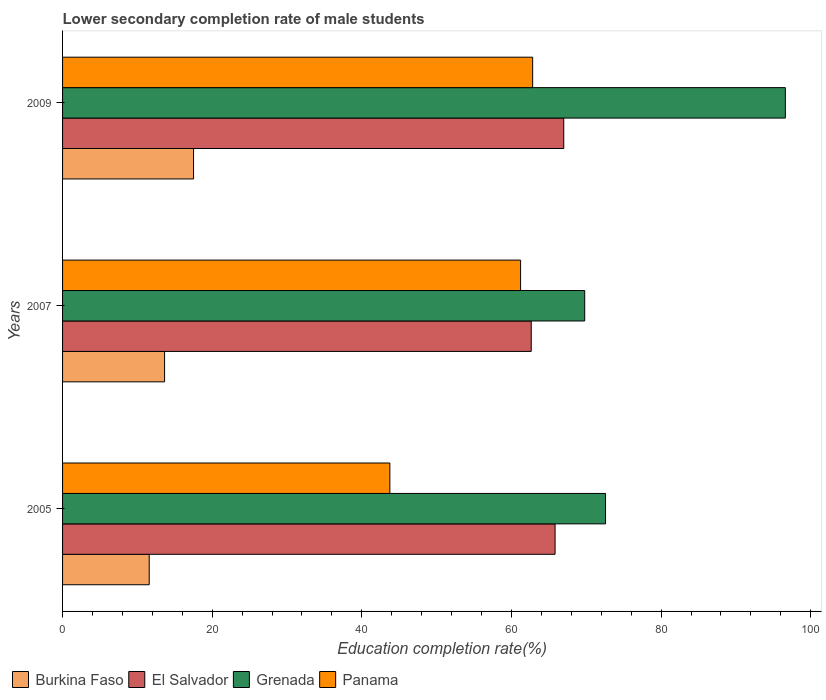How many different coloured bars are there?
Your answer should be very brief. 4. How many groups of bars are there?
Your response must be concise. 3. Are the number of bars on each tick of the Y-axis equal?
Offer a very short reply. Yes. How many bars are there on the 1st tick from the top?
Offer a terse response. 4. In how many cases, is the number of bars for a given year not equal to the number of legend labels?
Offer a very short reply. 0. What is the lower secondary completion rate of male students in Burkina Faso in 2005?
Keep it short and to the point. 11.58. Across all years, what is the maximum lower secondary completion rate of male students in El Salvador?
Make the answer very short. 66.99. Across all years, what is the minimum lower secondary completion rate of male students in Panama?
Keep it short and to the point. 43.74. In which year was the lower secondary completion rate of male students in El Salvador maximum?
Offer a very short reply. 2009. In which year was the lower secondary completion rate of male students in El Salvador minimum?
Provide a short and direct response. 2007. What is the total lower secondary completion rate of male students in Burkina Faso in the graph?
Provide a succinct answer. 42.73. What is the difference between the lower secondary completion rate of male students in Panama in 2005 and that in 2009?
Provide a succinct answer. -19.09. What is the difference between the lower secondary completion rate of male students in Panama in 2005 and the lower secondary completion rate of male students in Burkina Faso in 2007?
Keep it short and to the point. 30.11. What is the average lower secondary completion rate of male students in Burkina Faso per year?
Offer a very short reply. 14.24. In the year 2007, what is the difference between the lower secondary completion rate of male students in Panama and lower secondary completion rate of male students in El Salvador?
Keep it short and to the point. -1.42. In how many years, is the lower secondary completion rate of male students in Panama greater than 40 %?
Your answer should be compact. 3. What is the ratio of the lower secondary completion rate of male students in Panama in 2005 to that in 2007?
Offer a very short reply. 0.71. What is the difference between the highest and the second highest lower secondary completion rate of male students in Panama?
Offer a terse response. 1.61. What is the difference between the highest and the lowest lower secondary completion rate of male students in Grenada?
Provide a succinct answer. 26.82. In how many years, is the lower secondary completion rate of male students in El Salvador greater than the average lower secondary completion rate of male students in El Salvador taken over all years?
Your response must be concise. 2. What does the 4th bar from the top in 2005 represents?
Your response must be concise. Burkina Faso. What does the 3rd bar from the bottom in 2007 represents?
Offer a terse response. Grenada. Is it the case that in every year, the sum of the lower secondary completion rate of male students in El Salvador and lower secondary completion rate of male students in Panama is greater than the lower secondary completion rate of male students in Grenada?
Ensure brevity in your answer.  Yes. How many years are there in the graph?
Give a very brief answer. 3. What is the difference between two consecutive major ticks on the X-axis?
Offer a very short reply. 20. Where does the legend appear in the graph?
Your answer should be compact. Bottom left. How many legend labels are there?
Provide a succinct answer. 4. What is the title of the graph?
Your answer should be compact. Lower secondary completion rate of male students. Does "Morocco" appear as one of the legend labels in the graph?
Keep it short and to the point. No. What is the label or title of the X-axis?
Give a very brief answer. Education completion rate(%). What is the label or title of the Y-axis?
Ensure brevity in your answer.  Years. What is the Education completion rate(%) of Burkina Faso in 2005?
Your answer should be compact. 11.58. What is the Education completion rate(%) in El Salvador in 2005?
Your answer should be compact. 65.83. What is the Education completion rate(%) of Grenada in 2005?
Your response must be concise. 72.57. What is the Education completion rate(%) of Panama in 2005?
Give a very brief answer. 43.74. What is the Education completion rate(%) of Burkina Faso in 2007?
Your answer should be compact. 13.64. What is the Education completion rate(%) of El Salvador in 2007?
Ensure brevity in your answer.  62.64. What is the Education completion rate(%) in Grenada in 2007?
Keep it short and to the point. 69.79. What is the Education completion rate(%) of Panama in 2007?
Your answer should be compact. 61.22. What is the Education completion rate(%) of Burkina Faso in 2009?
Make the answer very short. 17.51. What is the Education completion rate(%) of El Salvador in 2009?
Your answer should be compact. 66.99. What is the Education completion rate(%) in Grenada in 2009?
Provide a short and direct response. 96.61. What is the Education completion rate(%) of Panama in 2009?
Make the answer very short. 62.83. Across all years, what is the maximum Education completion rate(%) in Burkina Faso?
Your answer should be compact. 17.51. Across all years, what is the maximum Education completion rate(%) of El Salvador?
Your answer should be very brief. 66.99. Across all years, what is the maximum Education completion rate(%) of Grenada?
Ensure brevity in your answer.  96.61. Across all years, what is the maximum Education completion rate(%) of Panama?
Offer a very short reply. 62.83. Across all years, what is the minimum Education completion rate(%) of Burkina Faso?
Provide a succinct answer. 11.58. Across all years, what is the minimum Education completion rate(%) of El Salvador?
Give a very brief answer. 62.64. Across all years, what is the minimum Education completion rate(%) in Grenada?
Offer a very short reply. 69.79. Across all years, what is the minimum Education completion rate(%) of Panama?
Offer a very short reply. 43.74. What is the total Education completion rate(%) of Burkina Faso in the graph?
Provide a short and direct response. 42.73. What is the total Education completion rate(%) of El Salvador in the graph?
Your answer should be very brief. 195.46. What is the total Education completion rate(%) in Grenada in the graph?
Your answer should be compact. 238.97. What is the total Education completion rate(%) in Panama in the graph?
Offer a very short reply. 167.79. What is the difference between the Education completion rate(%) of Burkina Faso in 2005 and that in 2007?
Make the answer very short. -2.06. What is the difference between the Education completion rate(%) of El Salvador in 2005 and that in 2007?
Give a very brief answer. 3.19. What is the difference between the Education completion rate(%) in Grenada in 2005 and that in 2007?
Give a very brief answer. 2.79. What is the difference between the Education completion rate(%) of Panama in 2005 and that in 2007?
Offer a terse response. -17.47. What is the difference between the Education completion rate(%) of Burkina Faso in 2005 and that in 2009?
Offer a very short reply. -5.93. What is the difference between the Education completion rate(%) in El Salvador in 2005 and that in 2009?
Keep it short and to the point. -1.16. What is the difference between the Education completion rate(%) in Grenada in 2005 and that in 2009?
Your answer should be very brief. -24.03. What is the difference between the Education completion rate(%) of Panama in 2005 and that in 2009?
Your answer should be very brief. -19.09. What is the difference between the Education completion rate(%) of Burkina Faso in 2007 and that in 2009?
Keep it short and to the point. -3.87. What is the difference between the Education completion rate(%) in El Salvador in 2007 and that in 2009?
Provide a succinct answer. -4.35. What is the difference between the Education completion rate(%) in Grenada in 2007 and that in 2009?
Offer a very short reply. -26.82. What is the difference between the Education completion rate(%) in Panama in 2007 and that in 2009?
Your answer should be very brief. -1.61. What is the difference between the Education completion rate(%) of Burkina Faso in 2005 and the Education completion rate(%) of El Salvador in 2007?
Your answer should be very brief. -51.06. What is the difference between the Education completion rate(%) in Burkina Faso in 2005 and the Education completion rate(%) in Grenada in 2007?
Give a very brief answer. -58.21. What is the difference between the Education completion rate(%) of Burkina Faso in 2005 and the Education completion rate(%) of Panama in 2007?
Your answer should be very brief. -49.64. What is the difference between the Education completion rate(%) in El Salvador in 2005 and the Education completion rate(%) in Grenada in 2007?
Your answer should be compact. -3.96. What is the difference between the Education completion rate(%) in El Salvador in 2005 and the Education completion rate(%) in Panama in 2007?
Offer a terse response. 4.61. What is the difference between the Education completion rate(%) in Grenada in 2005 and the Education completion rate(%) in Panama in 2007?
Keep it short and to the point. 11.35. What is the difference between the Education completion rate(%) of Burkina Faso in 2005 and the Education completion rate(%) of El Salvador in 2009?
Ensure brevity in your answer.  -55.41. What is the difference between the Education completion rate(%) in Burkina Faso in 2005 and the Education completion rate(%) in Grenada in 2009?
Offer a very short reply. -85.02. What is the difference between the Education completion rate(%) of Burkina Faso in 2005 and the Education completion rate(%) of Panama in 2009?
Provide a succinct answer. -51.25. What is the difference between the Education completion rate(%) in El Salvador in 2005 and the Education completion rate(%) in Grenada in 2009?
Provide a succinct answer. -30.78. What is the difference between the Education completion rate(%) of El Salvador in 2005 and the Education completion rate(%) of Panama in 2009?
Ensure brevity in your answer.  3. What is the difference between the Education completion rate(%) in Grenada in 2005 and the Education completion rate(%) in Panama in 2009?
Your answer should be compact. 9.74. What is the difference between the Education completion rate(%) of Burkina Faso in 2007 and the Education completion rate(%) of El Salvador in 2009?
Make the answer very short. -53.35. What is the difference between the Education completion rate(%) of Burkina Faso in 2007 and the Education completion rate(%) of Grenada in 2009?
Provide a succinct answer. -82.97. What is the difference between the Education completion rate(%) of Burkina Faso in 2007 and the Education completion rate(%) of Panama in 2009?
Keep it short and to the point. -49.19. What is the difference between the Education completion rate(%) in El Salvador in 2007 and the Education completion rate(%) in Grenada in 2009?
Your answer should be very brief. -33.97. What is the difference between the Education completion rate(%) in El Salvador in 2007 and the Education completion rate(%) in Panama in 2009?
Make the answer very short. -0.19. What is the difference between the Education completion rate(%) in Grenada in 2007 and the Education completion rate(%) in Panama in 2009?
Give a very brief answer. 6.96. What is the average Education completion rate(%) in Burkina Faso per year?
Keep it short and to the point. 14.24. What is the average Education completion rate(%) in El Salvador per year?
Provide a short and direct response. 65.15. What is the average Education completion rate(%) in Grenada per year?
Offer a very short reply. 79.66. What is the average Education completion rate(%) of Panama per year?
Your response must be concise. 55.93. In the year 2005, what is the difference between the Education completion rate(%) in Burkina Faso and Education completion rate(%) in El Salvador?
Give a very brief answer. -54.25. In the year 2005, what is the difference between the Education completion rate(%) in Burkina Faso and Education completion rate(%) in Grenada?
Give a very brief answer. -60.99. In the year 2005, what is the difference between the Education completion rate(%) of Burkina Faso and Education completion rate(%) of Panama?
Your answer should be very brief. -32.16. In the year 2005, what is the difference between the Education completion rate(%) in El Salvador and Education completion rate(%) in Grenada?
Your answer should be compact. -6.74. In the year 2005, what is the difference between the Education completion rate(%) in El Salvador and Education completion rate(%) in Panama?
Provide a succinct answer. 22.08. In the year 2005, what is the difference between the Education completion rate(%) in Grenada and Education completion rate(%) in Panama?
Your answer should be compact. 28.83. In the year 2007, what is the difference between the Education completion rate(%) of Burkina Faso and Education completion rate(%) of El Salvador?
Your answer should be very brief. -49. In the year 2007, what is the difference between the Education completion rate(%) in Burkina Faso and Education completion rate(%) in Grenada?
Provide a short and direct response. -56.15. In the year 2007, what is the difference between the Education completion rate(%) of Burkina Faso and Education completion rate(%) of Panama?
Make the answer very short. -47.58. In the year 2007, what is the difference between the Education completion rate(%) in El Salvador and Education completion rate(%) in Grenada?
Your answer should be very brief. -7.15. In the year 2007, what is the difference between the Education completion rate(%) in El Salvador and Education completion rate(%) in Panama?
Ensure brevity in your answer.  1.42. In the year 2007, what is the difference between the Education completion rate(%) in Grenada and Education completion rate(%) in Panama?
Offer a very short reply. 8.57. In the year 2009, what is the difference between the Education completion rate(%) in Burkina Faso and Education completion rate(%) in El Salvador?
Offer a very short reply. -49.48. In the year 2009, what is the difference between the Education completion rate(%) in Burkina Faso and Education completion rate(%) in Grenada?
Keep it short and to the point. -79.1. In the year 2009, what is the difference between the Education completion rate(%) in Burkina Faso and Education completion rate(%) in Panama?
Make the answer very short. -45.32. In the year 2009, what is the difference between the Education completion rate(%) in El Salvador and Education completion rate(%) in Grenada?
Your answer should be very brief. -29.62. In the year 2009, what is the difference between the Education completion rate(%) of El Salvador and Education completion rate(%) of Panama?
Give a very brief answer. 4.16. In the year 2009, what is the difference between the Education completion rate(%) in Grenada and Education completion rate(%) in Panama?
Your response must be concise. 33.77. What is the ratio of the Education completion rate(%) in Burkina Faso in 2005 to that in 2007?
Give a very brief answer. 0.85. What is the ratio of the Education completion rate(%) of El Salvador in 2005 to that in 2007?
Offer a very short reply. 1.05. What is the ratio of the Education completion rate(%) in Grenada in 2005 to that in 2007?
Offer a very short reply. 1.04. What is the ratio of the Education completion rate(%) in Panama in 2005 to that in 2007?
Give a very brief answer. 0.71. What is the ratio of the Education completion rate(%) of Burkina Faso in 2005 to that in 2009?
Ensure brevity in your answer.  0.66. What is the ratio of the Education completion rate(%) in El Salvador in 2005 to that in 2009?
Your answer should be compact. 0.98. What is the ratio of the Education completion rate(%) in Grenada in 2005 to that in 2009?
Provide a succinct answer. 0.75. What is the ratio of the Education completion rate(%) of Panama in 2005 to that in 2009?
Make the answer very short. 0.7. What is the ratio of the Education completion rate(%) of Burkina Faso in 2007 to that in 2009?
Keep it short and to the point. 0.78. What is the ratio of the Education completion rate(%) of El Salvador in 2007 to that in 2009?
Provide a succinct answer. 0.94. What is the ratio of the Education completion rate(%) in Grenada in 2007 to that in 2009?
Your answer should be very brief. 0.72. What is the ratio of the Education completion rate(%) of Panama in 2007 to that in 2009?
Give a very brief answer. 0.97. What is the difference between the highest and the second highest Education completion rate(%) of Burkina Faso?
Your answer should be very brief. 3.87. What is the difference between the highest and the second highest Education completion rate(%) of El Salvador?
Keep it short and to the point. 1.16. What is the difference between the highest and the second highest Education completion rate(%) of Grenada?
Your response must be concise. 24.03. What is the difference between the highest and the second highest Education completion rate(%) in Panama?
Your response must be concise. 1.61. What is the difference between the highest and the lowest Education completion rate(%) in Burkina Faso?
Give a very brief answer. 5.93. What is the difference between the highest and the lowest Education completion rate(%) of El Salvador?
Provide a short and direct response. 4.35. What is the difference between the highest and the lowest Education completion rate(%) of Grenada?
Keep it short and to the point. 26.82. What is the difference between the highest and the lowest Education completion rate(%) in Panama?
Keep it short and to the point. 19.09. 